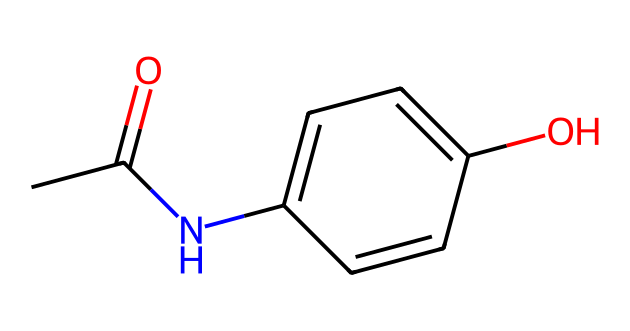What is the molecular formula of acetaminophen? The molecular formula can be derived by counting the atoms in the SMILES representation. Acetaminophen consists of 8 carbons (C), 9 hydrogens (H), 1 nitrogen (N), and 1 oxygen (O). Therefore, the molecular formula is C8H9NO2.
Answer: C8H9NO2 How many rings are present in the chemical structure of acetaminophen? By analyzing the SMILES representation, we see that "C1=CC=C(C=C1)" indicates the presence of a cyclic structure. This notation signifies one benzene ring in the structure, so there is one ring present.
Answer: 1 Identify the functional groups present in acetaminophen. The SMILES shows groups like "CC(=O)" indicating a carbonyl, and "NC" indicating an amine, in addition to the hydroxyl group "O". Thus, acetaminophen contains a hydroxyl (-OH), an amide (-NH), and a carbonyl (C=O) functional group.
Answer: hydroxyl, amide, carbonyl What type of drug is acetaminophen classified as? Acetaminophen is classified as an analgesic due to its pain-relieving properties, and it is also classified as an antipyretic due to its ability to reduce fever. Both functions stem from its chemical structure and functional groups.
Answer: analgesic, antipyretic Which part of the molecule contributes to its pain-relieving properties? The nitrogen atom in the amide functional group, along with the hydroxyl group, is key for the molecule's interaction with pain receptors in the body. The combination of these groups affects how acetaminophen binds and interacts at the molecular level for its analgesic effects.
Answer: nitrogen atom, hydroxyl group How many hydrogen atoms are directly bonded to the nitrogen atom in acetaminophen? In the structure represented by the SMILES, the nitrogen is connected only to one carbon and does not have any hydrogen atoms directly bonded to it, which is a characteristic of primary amines in this structure.
Answer: 0 